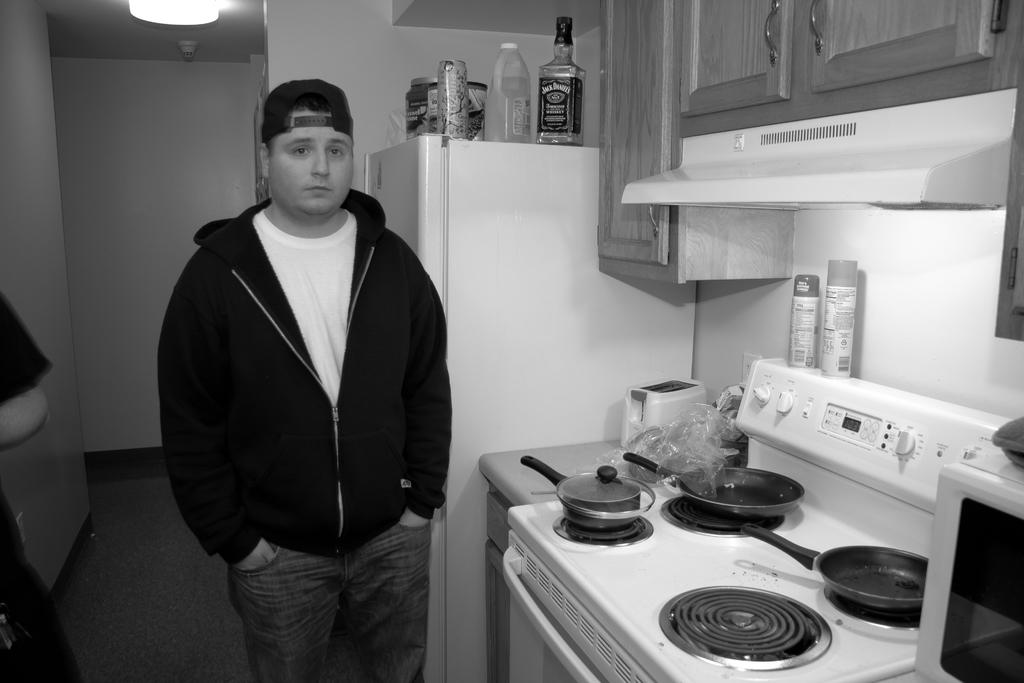<image>
Offer a succinct explanation of the picture presented. A bottle of Jack Daniels whisky sits above a refrigerator. 